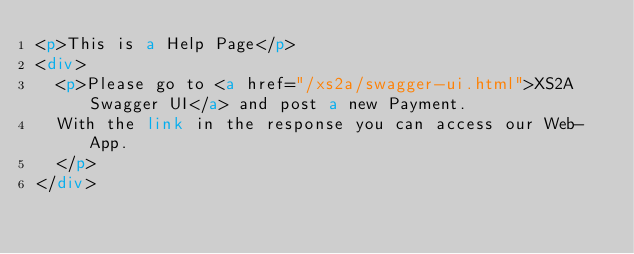<code> <loc_0><loc_0><loc_500><loc_500><_HTML_><p>This is a Help Page</p>
<div>
  <p>Please go to <a href="/xs2a/swagger-ui.html">XS2A Swagger UI</a> and post a new Payment.
  With the link in the response you can access our Web-App.
  </p>
</div>
</code> 